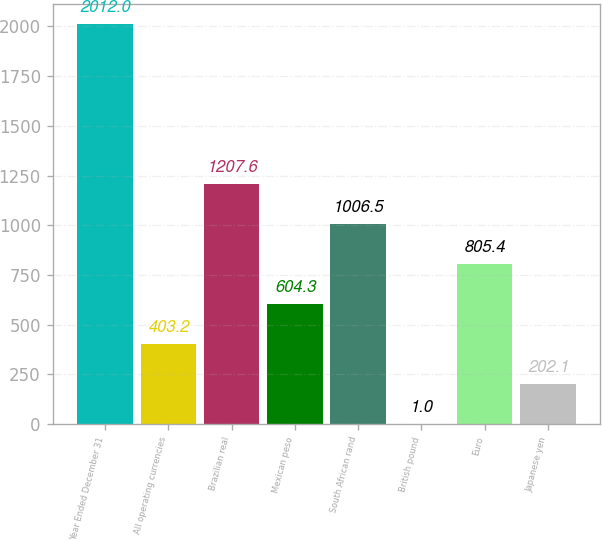<chart> <loc_0><loc_0><loc_500><loc_500><bar_chart><fcel>Year Ended December 31<fcel>All operating currencies<fcel>Brazilian real<fcel>Mexican peso<fcel>South African rand<fcel>British pound<fcel>Euro<fcel>Japanese yen<nl><fcel>2012<fcel>403.2<fcel>1207.6<fcel>604.3<fcel>1006.5<fcel>1<fcel>805.4<fcel>202.1<nl></chart> 